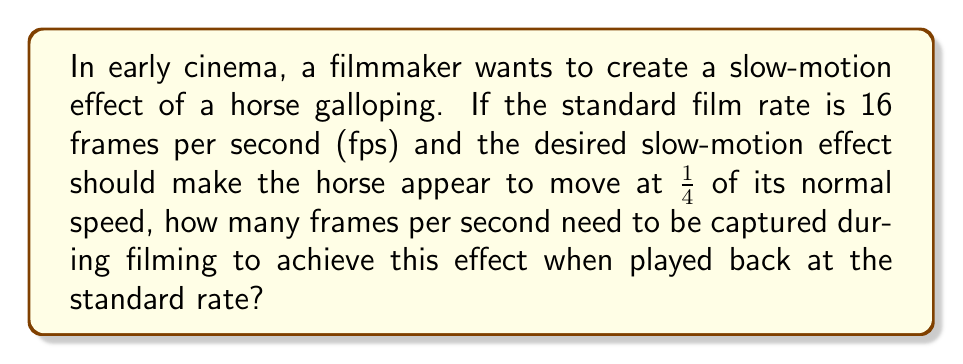Teach me how to tackle this problem. To solve this problem, let's break it down step-by-step:

1. Understand the given information:
   - Standard film rate: 16 fps
   - Desired slow-motion effect: 1/4 of normal speed

2. Set up the relationship between filming rate and playback rate:
   Let $x$ be the number of frames per second needed during filming.
   $$\frac{x \text{ fps (filming)}}{16 \text{ fps (playback)}} = \frac{1}{1/4} = 4$$

3. Solve for $x$:
   $$x = 16 \times 4 = 64 \text{ fps}$$

4. Interpretation:
   To make the horse appear to move at 1/4 of its normal speed when played back at 16 fps, we need to capture 64 frames per second during filming.

5. Verify:
   If we capture 64 frames in one second and play them back at 16 fps, it will take 4 seconds to show all 64 frames, creating the desired 1/4 speed slow-motion effect.
Answer: 64 fps 